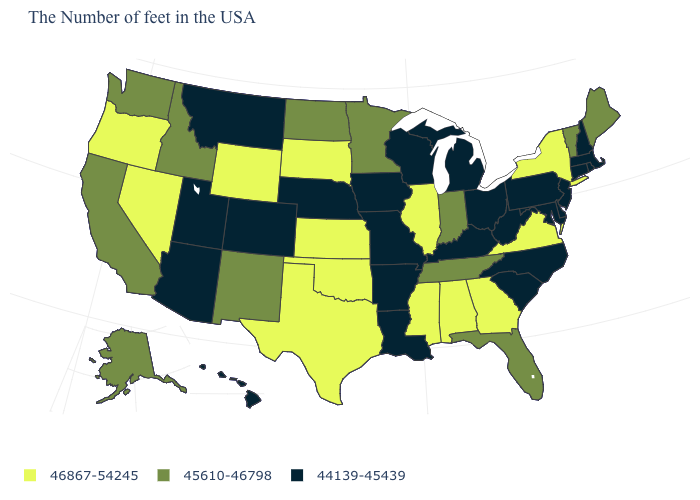What is the value of Tennessee?
Write a very short answer. 45610-46798. Which states have the highest value in the USA?
Quick response, please. New York, Virginia, Georgia, Alabama, Illinois, Mississippi, Kansas, Oklahoma, Texas, South Dakota, Wyoming, Nevada, Oregon. What is the value of Rhode Island?
Be succinct. 44139-45439. Which states hav the highest value in the MidWest?
Quick response, please. Illinois, Kansas, South Dakota. Does the first symbol in the legend represent the smallest category?
Quick response, please. No. What is the value of Wisconsin?
Write a very short answer. 44139-45439. Name the states that have a value in the range 44139-45439?
Quick response, please. Massachusetts, Rhode Island, New Hampshire, Connecticut, New Jersey, Delaware, Maryland, Pennsylvania, North Carolina, South Carolina, West Virginia, Ohio, Michigan, Kentucky, Wisconsin, Louisiana, Missouri, Arkansas, Iowa, Nebraska, Colorado, Utah, Montana, Arizona, Hawaii. Name the states that have a value in the range 46867-54245?
Write a very short answer. New York, Virginia, Georgia, Alabama, Illinois, Mississippi, Kansas, Oklahoma, Texas, South Dakota, Wyoming, Nevada, Oregon. Does Indiana have the same value as Hawaii?
Concise answer only. No. Among the states that border South Dakota , which have the highest value?
Concise answer only. Wyoming. Name the states that have a value in the range 45610-46798?
Keep it brief. Maine, Vermont, Florida, Indiana, Tennessee, Minnesota, North Dakota, New Mexico, Idaho, California, Washington, Alaska. How many symbols are there in the legend?
Answer briefly. 3. What is the highest value in the USA?
Give a very brief answer. 46867-54245. Among the states that border Missouri , which have the highest value?
Short answer required. Illinois, Kansas, Oklahoma. What is the value of Delaware?
Answer briefly. 44139-45439. 